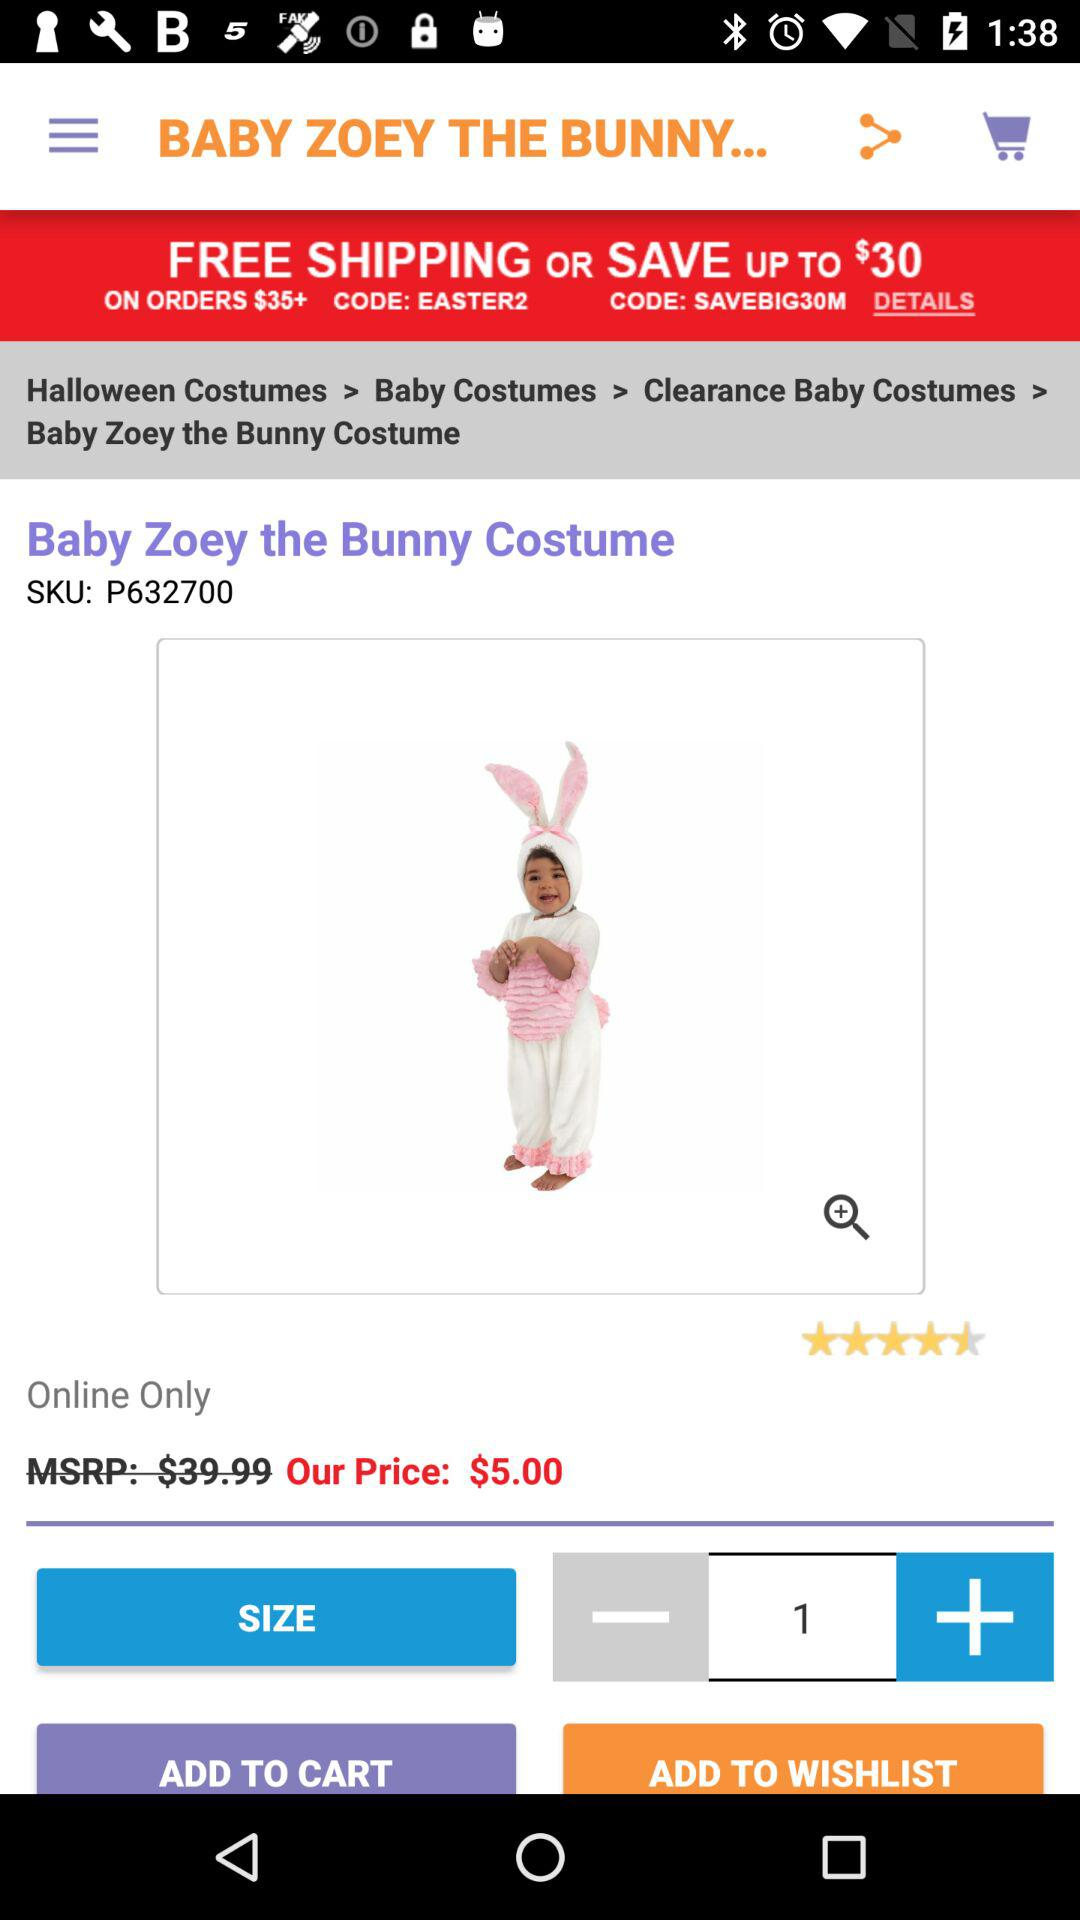How many stars are given to "Baby Zoey the Bunny Costume"? The given stars are 4.5. 